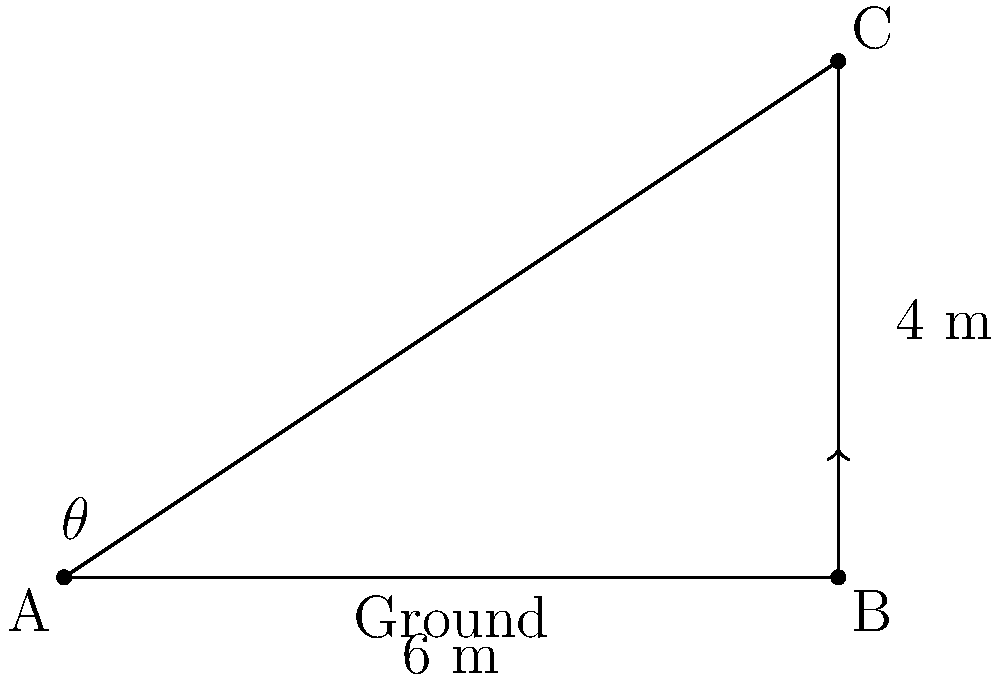At a tennis tournament in Columbus, Ohio, you're analyzing serves from the sideline. A player serves the ball from point A, and it reaches its maximum height of 4 meters directly above point B, which is 6 meters away from A. What is the angle of elevation ($\theta$) of the serve? To find the angle of elevation ($\theta$), we need to use trigonometry in the right triangle ABC. Let's approach this step-by-step:

1) In the right triangle ABC:
   - The adjacent side (AB) is 6 meters
   - The opposite side (BC) is 4 meters

2) We need to find the angle $\theta$ at point A. The tangent function relates the opposite and adjacent sides:

   $\tan(\theta) = \frac{\text{opposite}}{\text{adjacent}}$

3) Plugging in our values:

   $\tan(\theta) = \frac{4}{6}$

4) To find $\theta$, we need to use the inverse tangent (arctan or $\tan^{-1}$):

   $\theta = \tan^{-1}(\frac{4}{6})$

5) Using a calculator or trigonometric tables:

   $\theta \approx 33.69°$

Therefore, the angle of elevation of the tennis serve is approximately 33.69°.
Answer: $33.69°$ 